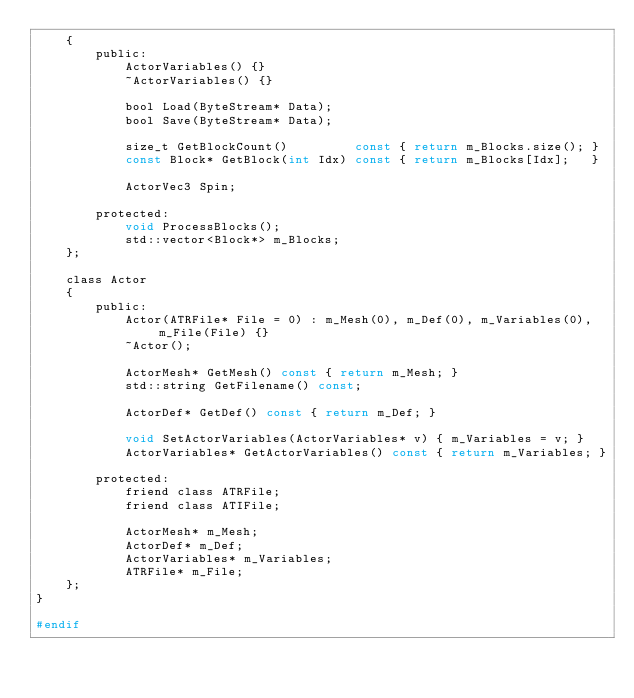Convert code to text. <code><loc_0><loc_0><loc_500><loc_500><_C_>    {
        public:
            ActorVariables() {}
            ~ActorVariables() {}

            bool Load(ByteStream* Data);
            bool Save(ByteStream* Data);

            size_t GetBlockCount()         const { return m_Blocks.size(); }
            const Block* GetBlock(int Idx) const { return m_Blocks[Idx];   }

            ActorVec3 Spin;

        protected:
            void ProcessBlocks();
            std::vector<Block*> m_Blocks;
    };

    class Actor
    {
        public:
            Actor(ATRFile* File = 0) : m_Mesh(0), m_Def(0), m_Variables(0), m_File(File) {}
            ~Actor();

            ActorMesh* GetMesh() const { return m_Mesh; }
            std::string GetFilename() const;

            ActorDef* GetDef() const { return m_Def; }

            void SetActorVariables(ActorVariables* v) { m_Variables = v; }
            ActorVariables* GetActorVariables() const { return m_Variables; }

        protected:
            friend class ATRFile;
            friend class ATIFile;

            ActorMesh* m_Mesh;
            ActorDef* m_Def;
            ActorVariables* m_Variables;
            ATRFile* m_File;
    };
}

#endif
</code> 